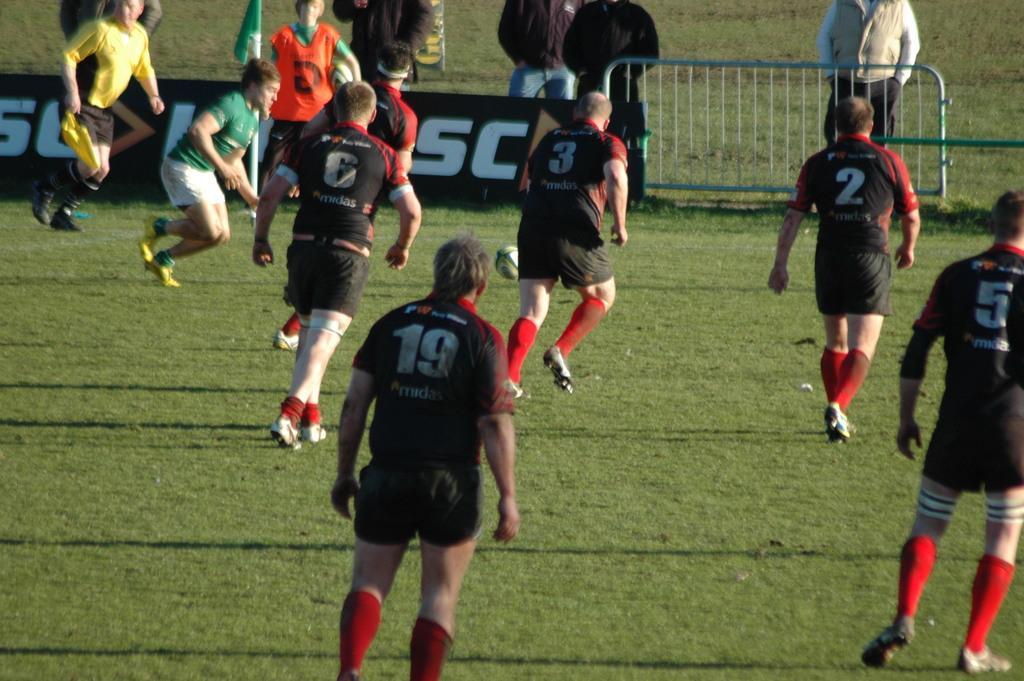Could you give a brief overview of what you see in this image? In this picture we can see a group of people where some are running on the ground and some are standing at the fence and in the background we can see a flag, grass. 